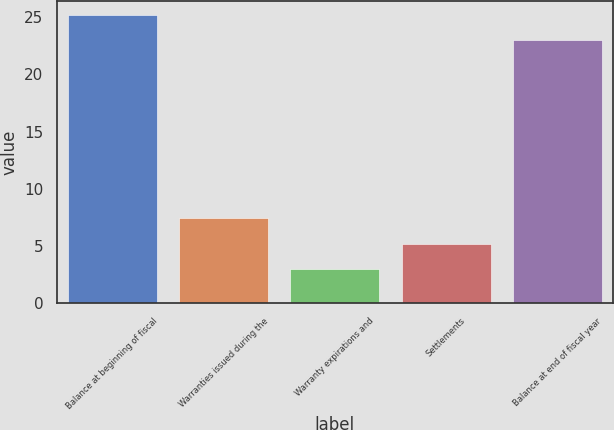Convert chart to OTSL. <chart><loc_0><loc_0><loc_500><loc_500><bar_chart><fcel>Balance at beginning of fiscal<fcel>Warranties issued during the<fcel>Warranty expirations and<fcel>Settlements<fcel>Balance at end of fiscal year<nl><fcel>25.2<fcel>7.4<fcel>3<fcel>5.2<fcel>23<nl></chart> 